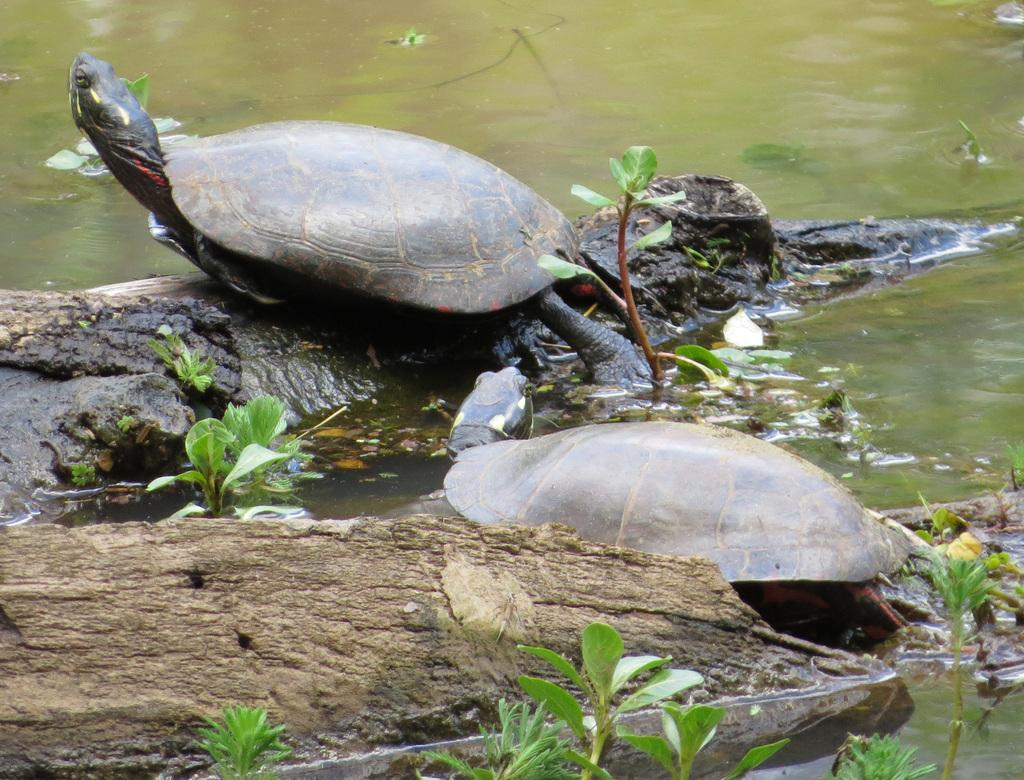How many turtles are in the image? There are two turtles in the image. What are the turtles resting on? The turtles are on wooden logs. What other living organisms can be seen in the image? There are plants in the image. What is the primary element visible in the image? There is water visible in the image. What type of society can be observed in the image? There is no society present in the image; it features two turtles on wooden logs with plants and water visible. 